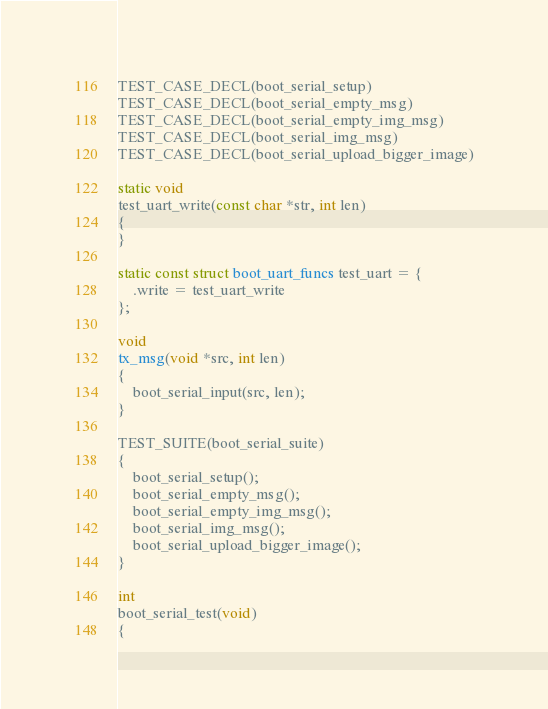Convert code to text. <code><loc_0><loc_0><loc_500><loc_500><_C_>TEST_CASE_DECL(boot_serial_setup)
TEST_CASE_DECL(boot_serial_empty_msg)
TEST_CASE_DECL(boot_serial_empty_img_msg)
TEST_CASE_DECL(boot_serial_img_msg)
TEST_CASE_DECL(boot_serial_upload_bigger_image)

static void
test_uart_write(const char *str, int len)
{
}

static const struct boot_uart_funcs test_uart = {
    .write = test_uart_write
};

void
tx_msg(void *src, int len)
{
    boot_serial_input(src, len);
}

TEST_SUITE(boot_serial_suite)
{
    boot_serial_setup();
    boot_serial_empty_msg();
    boot_serial_empty_img_msg();
    boot_serial_img_msg();
    boot_serial_upload_bigger_image();
}

int
boot_serial_test(void)
{</code> 